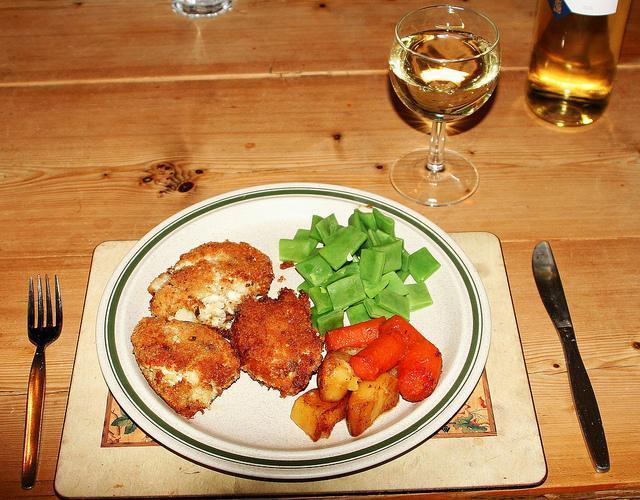How many forks are there?
Give a very brief answer. 1. How many bottles can be seen?
Give a very brief answer. 1. How many boys take the pizza in the image?
Give a very brief answer. 0. 